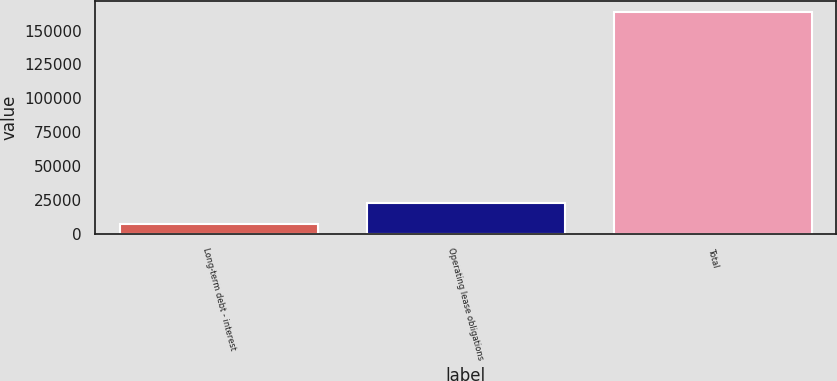Convert chart to OTSL. <chart><loc_0><loc_0><loc_500><loc_500><bar_chart><fcel>Long-term debt - interest<fcel>Operating lease obligations<fcel>Total<nl><fcel>6962<fcel>22607.7<fcel>163419<nl></chart> 